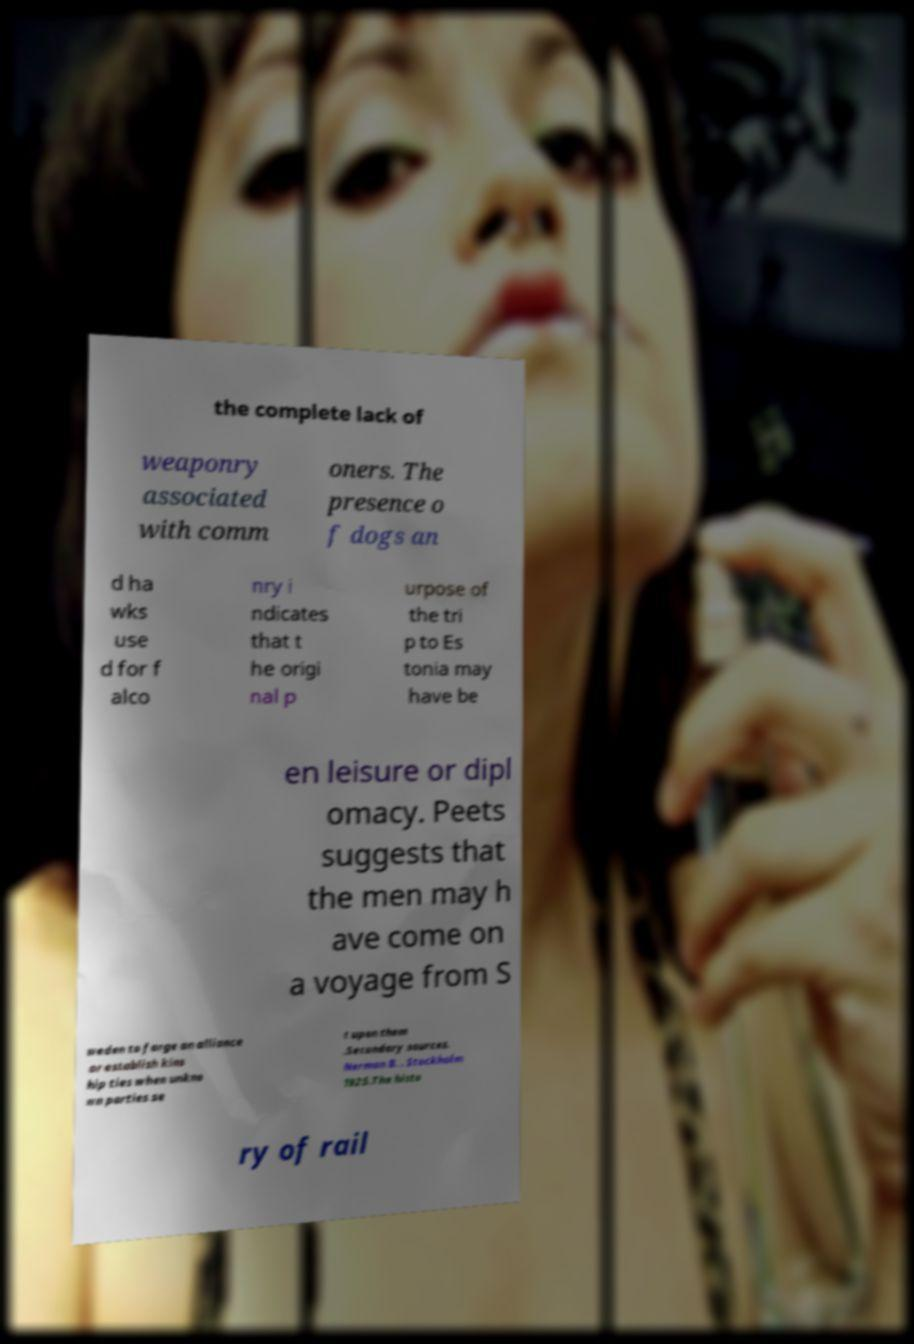For documentation purposes, I need the text within this image transcribed. Could you provide that? the complete lack of weaponry associated with comm oners. The presence o f dogs an d ha wks use d for f alco nry i ndicates that t he origi nal p urpose of the tri p to Es tonia may have be en leisure or dipl omacy. Peets suggests that the men may h ave come on a voyage from S weden to forge an alliance or establish kins hip ties when unkno wn parties se t upon them .Secondary sources. Nerman B. . Stockholm 1925.The histo ry of rail 